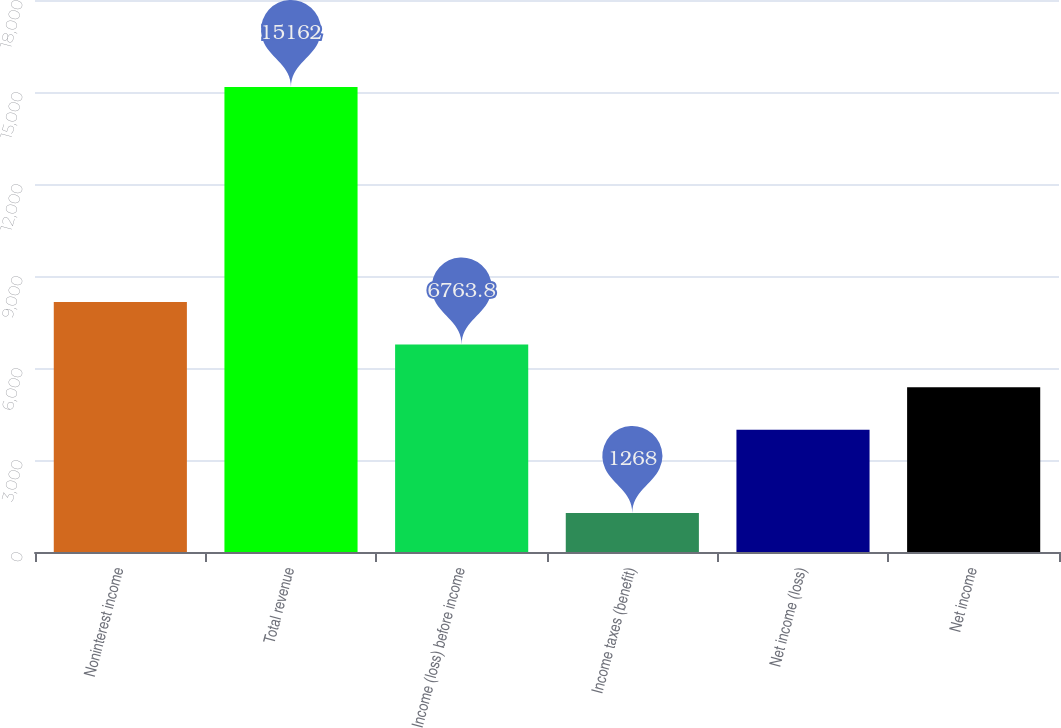<chart> <loc_0><loc_0><loc_500><loc_500><bar_chart><fcel>Noninterest income<fcel>Total revenue<fcel>Income (loss) before income<fcel>Income taxes (benefit)<fcel>Net income (loss)<fcel>Net income<nl><fcel>8153.2<fcel>15162<fcel>6763.8<fcel>1268<fcel>3985<fcel>5374.4<nl></chart> 